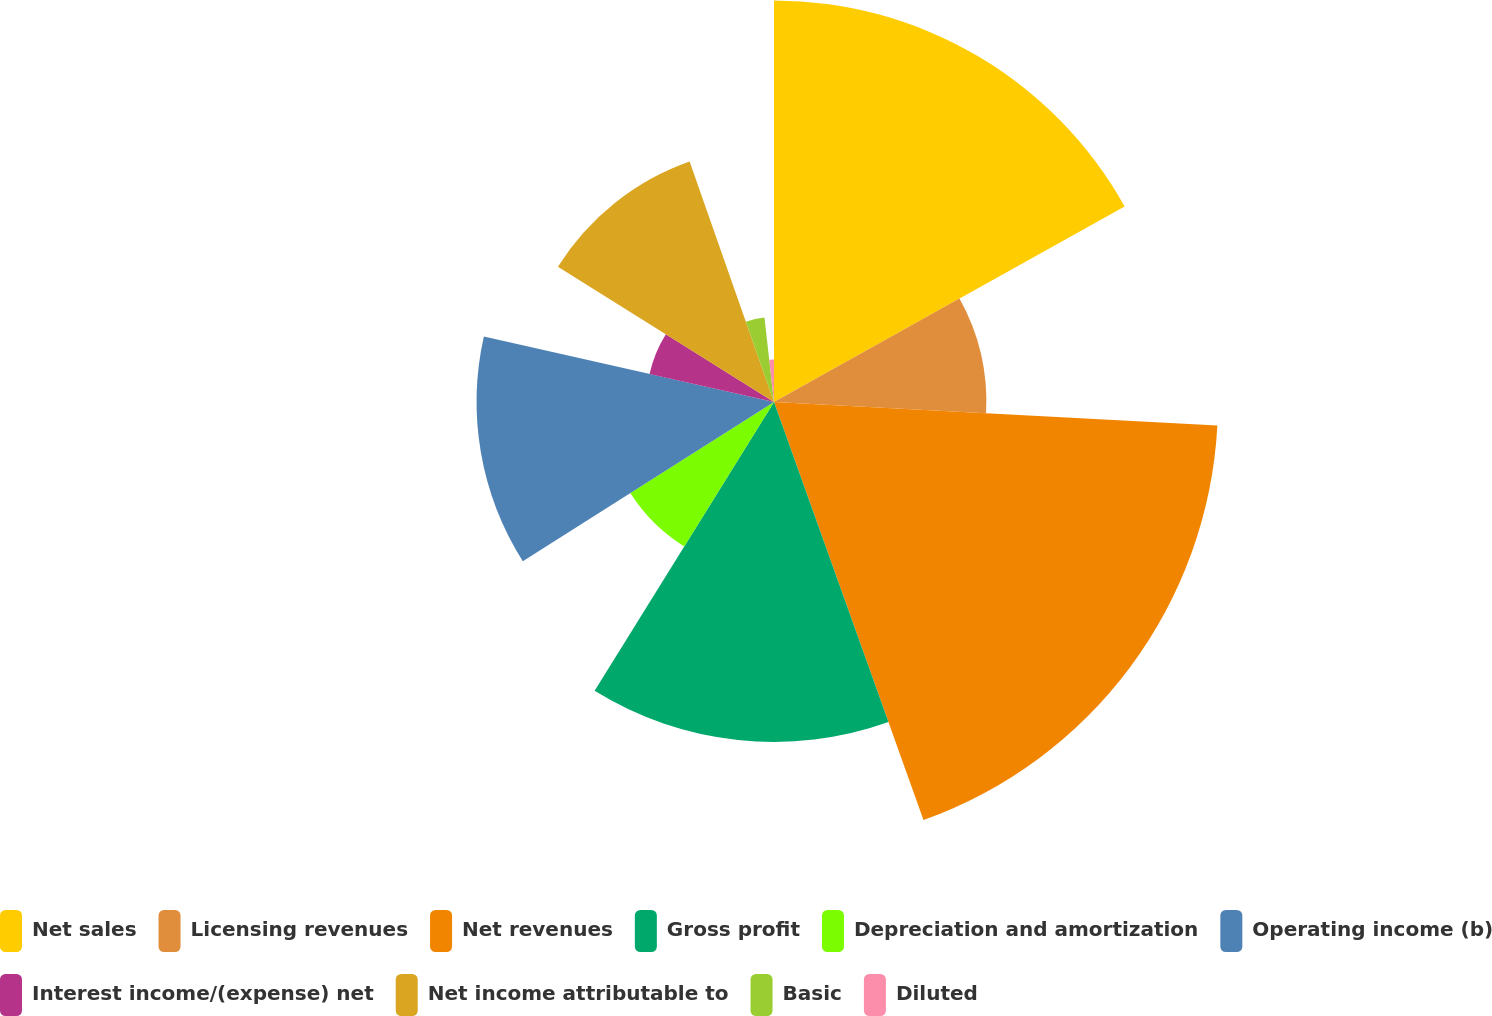Convert chart. <chart><loc_0><loc_0><loc_500><loc_500><pie_chart><fcel>Net sales<fcel>Licensing revenues<fcel>Net revenues<fcel>Gross profit<fcel>Depreciation and amortization<fcel>Operating income (b)<fcel>Interest income/(expense) net<fcel>Net income attributable to<fcel>Basic<fcel>Diluted<nl><fcel>16.9%<fcel>8.94%<fcel>18.69%<fcel>14.31%<fcel>7.16%<fcel>12.52%<fcel>5.37%<fcel>10.73%<fcel>3.58%<fcel>1.79%<nl></chart> 